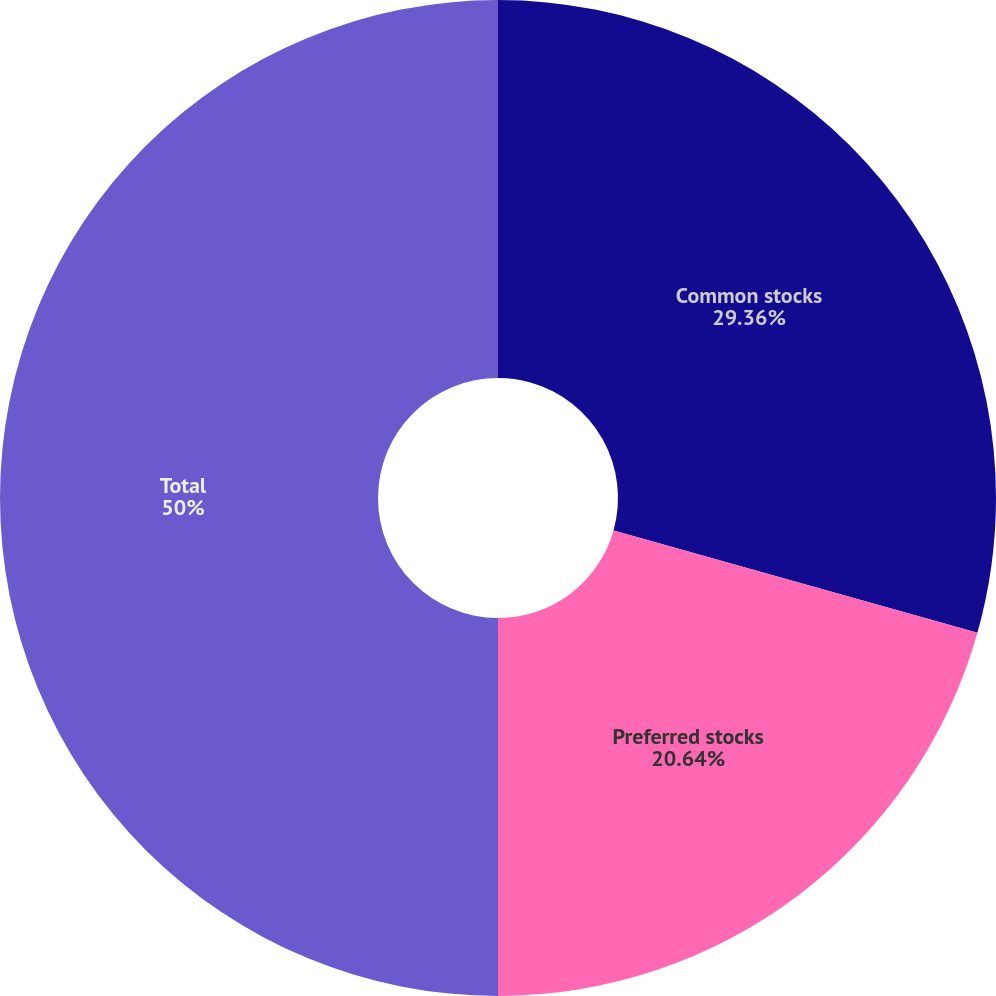<chart> <loc_0><loc_0><loc_500><loc_500><pie_chart><fcel>Common stocks<fcel>Preferred stocks<fcel>Total<nl><fcel>29.36%<fcel>20.64%<fcel>50.0%<nl></chart> 